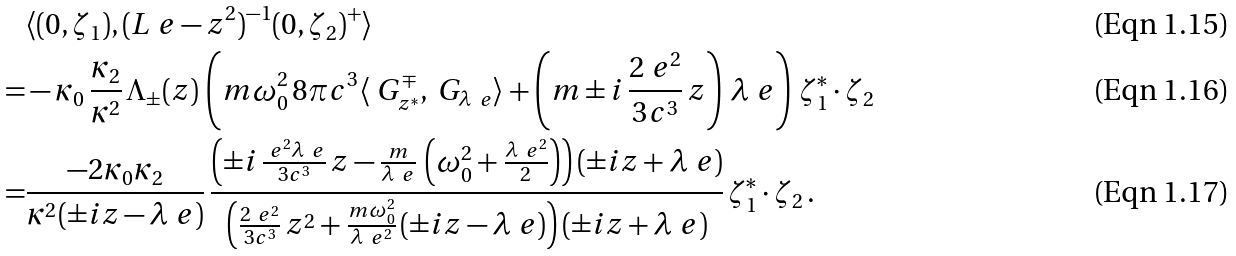<formula> <loc_0><loc_0><loc_500><loc_500>& \langle ( 0 , \zeta _ { 1 } ) , ( L _ { \ } e - z ^ { 2 } ) ^ { - 1 } ( 0 , \zeta _ { 2 } ) ^ { + } \rangle \\ = & - \kappa _ { 0 } \, \frac { \kappa _ { 2 } } { \kappa ^ { 2 } } \, \Lambda _ { \pm } ( z ) \, \left ( m \omega _ { 0 } ^ { 2 } \, 8 \pi c ^ { 3 } \langle \ G _ { z ^ { * } } ^ { \mp } , \ G _ { \lambda _ { \ } e } \rangle + \left ( m \pm i \, \frac { 2 \ e ^ { 2 } } { 3 c ^ { 3 } } \, z \right ) \, \lambda _ { \ } e \right ) \, \zeta _ { 1 } ^ { * } \cdot \zeta _ { 2 } \\ = & \frac { - 2 \kappa _ { 0 } \kappa _ { 2 } } { \kappa ^ { 2 } ( \pm i z - \lambda _ { \ } e ) } \, \frac { \left ( \pm i \, \frac { \ e ^ { 2 } \lambda _ { \ } e } { 3 c ^ { 3 } } \, z - \frac { m } { \lambda _ { \ } e } \, \left ( { \omega _ { 0 } ^ { 2 } } + \frac { \lambda _ { \ } e ^ { 2 } } { 2 } \right ) \right ) ( \pm i z + \lambda _ { \ } e ) } { \left ( \frac { 2 \ e ^ { 2 } } { 3 c ^ { 3 } } \, z ^ { 2 } + \frac { m \omega _ { 0 } ^ { 2 } } { \lambda _ { \ } e ^ { 2 } } \, ( \pm i z - \lambda _ { \ } e ) \right ) ( \pm i z + \lambda _ { \ } e ) } \, \zeta _ { 1 } ^ { * } \cdot \zeta _ { 2 } \, .</formula> 